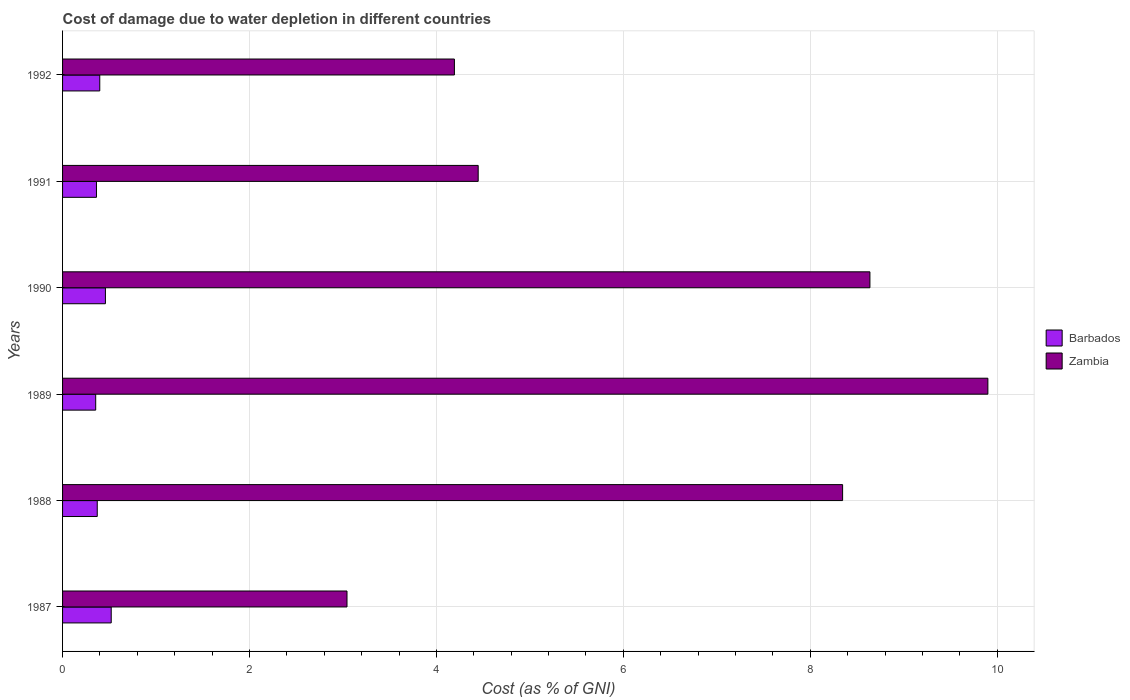Are the number of bars per tick equal to the number of legend labels?
Ensure brevity in your answer.  Yes. How many bars are there on the 6th tick from the top?
Your answer should be very brief. 2. What is the label of the 1st group of bars from the top?
Provide a short and direct response. 1992. What is the cost of damage caused due to water depletion in Zambia in 1991?
Provide a short and direct response. 4.45. Across all years, what is the maximum cost of damage caused due to water depletion in Barbados?
Keep it short and to the point. 0.52. Across all years, what is the minimum cost of damage caused due to water depletion in Zambia?
Your answer should be very brief. 3.04. In which year was the cost of damage caused due to water depletion in Barbados minimum?
Give a very brief answer. 1989. What is the total cost of damage caused due to water depletion in Zambia in the graph?
Ensure brevity in your answer.  38.57. What is the difference between the cost of damage caused due to water depletion in Barbados in 1990 and that in 1992?
Keep it short and to the point. 0.06. What is the difference between the cost of damage caused due to water depletion in Zambia in 1990 and the cost of damage caused due to water depletion in Barbados in 1989?
Your answer should be very brief. 8.28. What is the average cost of damage caused due to water depletion in Barbados per year?
Offer a terse response. 0.41. In the year 1987, what is the difference between the cost of damage caused due to water depletion in Zambia and cost of damage caused due to water depletion in Barbados?
Provide a succinct answer. 2.52. In how many years, is the cost of damage caused due to water depletion in Zambia greater than 7.6 %?
Offer a very short reply. 3. What is the ratio of the cost of damage caused due to water depletion in Zambia in 1987 to that in 1992?
Provide a succinct answer. 0.73. Is the cost of damage caused due to water depletion in Zambia in 1987 less than that in 1990?
Keep it short and to the point. Yes. What is the difference between the highest and the second highest cost of damage caused due to water depletion in Barbados?
Offer a very short reply. 0.06. What is the difference between the highest and the lowest cost of damage caused due to water depletion in Zambia?
Offer a very short reply. 6.86. What does the 1st bar from the top in 1989 represents?
Offer a terse response. Zambia. What does the 1st bar from the bottom in 1990 represents?
Keep it short and to the point. Barbados. Are all the bars in the graph horizontal?
Provide a succinct answer. Yes. How many years are there in the graph?
Make the answer very short. 6. Does the graph contain any zero values?
Make the answer very short. No. What is the title of the graph?
Your answer should be compact. Cost of damage due to water depletion in different countries. Does "Kosovo" appear as one of the legend labels in the graph?
Make the answer very short. No. What is the label or title of the X-axis?
Ensure brevity in your answer.  Cost (as % of GNI). What is the label or title of the Y-axis?
Provide a short and direct response. Years. What is the Cost (as % of GNI) in Barbados in 1987?
Your answer should be very brief. 0.52. What is the Cost (as % of GNI) in Zambia in 1987?
Your response must be concise. 3.04. What is the Cost (as % of GNI) in Barbados in 1988?
Give a very brief answer. 0.37. What is the Cost (as % of GNI) of Zambia in 1988?
Offer a very short reply. 8.35. What is the Cost (as % of GNI) in Barbados in 1989?
Make the answer very short. 0.35. What is the Cost (as % of GNI) in Zambia in 1989?
Offer a very short reply. 9.9. What is the Cost (as % of GNI) of Barbados in 1990?
Ensure brevity in your answer.  0.46. What is the Cost (as % of GNI) of Zambia in 1990?
Your response must be concise. 8.64. What is the Cost (as % of GNI) in Barbados in 1991?
Keep it short and to the point. 0.36. What is the Cost (as % of GNI) of Zambia in 1991?
Provide a short and direct response. 4.45. What is the Cost (as % of GNI) in Barbados in 1992?
Offer a very short reply. 0.4. What is the Cost (as % of GNI) of Zambia in 1992?
Offer a terse response. 4.19. Across all years, what is the maximum Cost (as % of GNI) in Barbados?
Give a very brief answer. 0.52. Across all years, what is the maximum Cost (as % of GNI) of Zambia?
Your response must be concise. 9.9. Across all years, what is the minimum Cost (as % of GNI) of Barbados?
Ensure brevity in your answer.  0.35. Across all years, what is the minimum Cost (as % of GNI) in Zambia?
Your answer should be very brief. 3.04. What is the total Cost (as % of GNI) of Barbados in the graph?
Your answer should be compact. 2.47. What is the total Cost (as % of GNI) of Zambia in the graph?
Make the answer very short. 38.57. What is the difference between the Cost (as % of GNI) in Barbados in 1987 and that in 1988?
Your answer should be very brief. 0.15. What is the difference between the Cost (as % of GNI) in Zambia in 1987 and that in 1988?
Ensure brevity in your answer.  -5.3. What is the difference between the Cost (as % of GNI) in Barbados in 1987 and that in 1989?
Make the answer very short. 0.17. What is the difference between the Cost (as % of GNI) of Zambia in 1987 and that in 1989?
Give a very brief answer. -6.86. What is the difference between the Cost (as % of GNI) of Barbados in 1987 and that in 1990?
Make the answer very short. 0.06. What is the difference between the Cost (as % of GNI) in Zambia in 1987 and that in 1990?
Give a very brief answer. -5.6. What is the difference between the Cost (as % of GNI) of Barbados in 1987 and that in 1991?
Your response must be concise. 0.16. What is the difference between the Cost (as % of GNI) in Zambia in 1987 and that in 1991?
Offer a very short reply. -1.4. What is the difference between the Cost (as % of GNI) of Barbados in 1987 and that in 1992?
Your answer should be compact. 0.12. What is the difference between the Cost (as % of GNI) of Zambia in 1987 and that in 1992?
Offer a very short reply. -1.15. What is the difference between the Cost (as % of GNI) of Barbados in 1988 and that in 1989?
Ensure brevity in your answer.  0.02. What is the difference between the Cost (as % of GNI) in Zambia in 1988 and that in 1989?
Give a very brief answer. -1.55. What is the difference between the Cost (as % of GNI) in Barbados in 1988 and that in 1990?
Give a very brief answer. -0.09. What is the difference between the Cost (as % of GNI) in Zambia in 1988 and that in 1990?
Keep it short and to the point. -0.29. What is the difference between the Cost (as % of GNI) in Barbados in 1988 and that in 1991?
Provide a succinct answer. 0.01. What is the difference between the Cost (as % of GNI) in Zambia in 1988 and that in 1991?
Offer a very short reply. 3.9. What is the difference between the Cost (as % of GNI) in Barbados in 1988 and that in 1992?
Offer a very short reply. -0.03. What is the difference between the Cost (as % of GNI) in Zambia in 1988 and that in 1992?
Your answer should be very brief. 4.15. What is the difference between the Cost (as % of GNI) of Barbados in 1989 and that in 1990?
Your answer should be compact. -0.1. What is the difference between the Cost (as % of GNI) in Zambia in 1989 and that in 1990?
Make the answer very short. 1.26. What is the difference between the Cost (as % of GNI) of Barbados in 1989 and that in 1991?
Give a very brief answer. -0.01. What is the difference between the Cost (as % of GNI) in Zambia in 1989 and that in 1991?
Give a very brief answer. 5.45. What is the difference between the Cost (as % of GNI) of Barbados in 1989 and that in 1992?
Offer a very short reply. -0.04. What is the difference between the Cost (as % of GNI) in Zambia in 1989 and that in 1992?
Give a very brief answer. 5.71. What is the difference between the Cost (as % of GNI) in Barbados in 1990 and that in 1991?
Provide a succinct answer. 0.1. What is the difference between the Cost (as % of GNI) of Zambia in 1990 and that in 1991?
Your answer should be very brief. 4.19. What is the difference between the Cost (as % of GNI) in Barbados in 1990 and that in 1992?
Your response must be concise. 0.06. What is the difference between the Cost (as % of GNI) in Zambia in 1990 and that in 1992?
Offer a very short reply. 4.45. What is the difference between the Cost (as % of GNI) in Barbados in 1991 and that in 1992?
Make the answer very short. -0.04. What is the difference between the Cost (as % of GNI) in Zambia in 1991 and that in 1992?
Your answer should be compact. 0.25. What is the difference between the Cost (as % of GNI) in Barbados in 1987 and the Cost (as % of GNI) in Zambia in 1988?
Offer a very short reply. -7.83. What is the difference between the Cost (as % of GNI) of Barbados in 1987 and the Cost (as % of GNI) of Zambia in 1989?
Your answer should be very brief. -9.38. What is the difference between the Cost (as % of GNI) of Barbados in 1987 and the Cost (as % of GNI) of Zambia in 1990?
Keep it short and to the point. -8.12. What is the difference between the Cost (as % of GNI) of Barbados in 1987 and the Cost (as % of GNI) of Zambia in 1991?
Keep it short and to the point. -3.93. What is the difference between the Cost (as % of GNI) in Barbados in 1987 and the Cost (as % of GNI) in Zambia in 1992?
Make the answer very short. -3.67. What is the difference between the Cost (as % of GNI) of Barbados in 1988 and the Cost (as % of GNI) of Zambia in 1989?
Make the answer very short. -9.53. What is the difference between the Cost (as % of GNI) of Barbados in 1988 and the Cost (as % of GNI) of Zambia in 1990?
Ensure brevity in your answer.  -8.27. What is the difference between the Cost (as % of GNI) of Barbados in 1988 and the Cost (as % of GNI) of Zambia in 1991?
Ensure brevity in your answer.  -4.08. What is the difference between the Cost (as % of GNI) in Barbados in 1988 and the Cost (as % of GNI) in Zambia in 1992?
Give a very brief answer. -3.82. What is the difference between the Cost (as % of GNI) in Barbados in 1989 and the Cost (as % of GNI) in Zambia in 1990?
Offer a very short reply. -8.28. What is the difference between the Cost (as % of GNI) of Barbados in 1989 and the Cost (as % of GNI) of Zambia in 1991?
Provide a succinct answer. -4.09. What is the difference between the Cost (as % of GNI) in Barbados in 1989 and the Cost (as % of GNI) in Zambia in 1992?
Keep it short and to the point. -3.84. What is the difference between the Cost (as % of GNI) of Barbados in 1990 and the Cost (as % of GNI) of Zambia in 1991?
Your response must be concise. -3.99. What is the difference between the Cost (as % of GNI) of Barbados in 1990 and the Cost (as % of GNI) of Zambia in 1992?
Ensure brevity in your answer.  -3.73. What is the difference between the Cost (as % of GNI) in Barbados in 1991 and the Cost (as % of GNI) in Zambia in 1992?
Your answer should be very brief. -3.83. What is the average Cost (as % of GNI) in Barbados per year?
Provide a succinct answer. 0.41. What is the average Cost (as % of GNI) of Zambia per year?
Your response must be concise. 6.43. In the year 1987, what is the difference between the Cost (as % of GNI) in Barbados and Cost (as % of GNI) in Zambia?
Ensure brevity in your answer.  -2.52. In the year 1988, what is the difference between the Cost (as % of GNI) in Barbados and Cost (as % of GNI) in Zambia?
Ensure brevity in your answer.  -7.97. In the year 1989, what is the difference between the Cost (as % of GNI) of Barbados and Cost (as % of GNI) of Zambia?
Provide a succinct answer. -9.55. In the year 1990, what is the difference between the Cost (as % of GNI) in Barbados and Cost (as % of GNI) in Zambia?
Provide a succinct answer. -8.18. In the year 1991, what is the difference between the Cost (as % of GNI) of Barbados and Cost (as % of GNI) of Zambia?
Make the answer very short. -4.08. In the year 1992, what is the difference between the Cost (as % of GNI) in Barbados and Cost (as % of GNI) in Zambia?
Keep it short and to the point. -3.79. What is the ratio of the Cost (as % of GNI) of Barbados in 1987 to that in 1988?
Provide a short and direct response. 1.4. What is the ratio of the Cost (as % of GNI) of Zambia in 1987 to that in 1988?
Offer a very short reply. 0.36. What is the ratio of the Cost (as % of GNI) of Barbados in 1987 to that in 1989?
Keep it short and to the point. 1.47. What is the ratio of the Cost (as % of GNI) in Zambia in 1987 to that in 1989?
Keep it short and to the point. 0.31. What is the ratio of the Cost (as % of GNI) of Barbados in 1987 to that in 1990?
Keep it short and to the point. 1.14. What is the ratio of the Cost (as % of GNI) in Zambia in 1987 to that in 1990?
Provide a succinct answer. 0.35. What is the ratio of the Cost (as % of GNI) of Barbados in 1987 to that in 1991?
Offer a very short reply. 1.44. What is the ratio of the Cost (as % of GNI) in Zambia in 1987 to that in 1991?
Your answer should be very brief. 0.68. What is the ratio of the Cost (as % of GNI) of Barbados in 1987 to that in 1992?
Provide a succinct answer. 1.31. What is the ratio of the Cost (as % of GNI) of Zambia in 1987 to that in 1992?
Your answer should be compact. 0.73. What is the ratio of the Cost (as % of GNI) in Barbados in 1988 to that in 1989?
Offer a terse response. 1.05. What is the ratio of the Cost (as % of GNI) of Zambia in 1988 to that in 1989?
Your answer should be very brief. 0.84. What is the ratio of the Cost (as % of GNI) of Barbados in 1988 to that in 1990?
Your answer should be compact. 0.81. What is the ratio of the Cost (as % of GNI) in Zambia in 1988 to that in 1990?
Keep it short and to the point. 0.97. What is the ratio of the Cost (as % of GNI) in Barbados in 1988 to that in 1991?
Your answer should be very brief. 1.02. What is the ratio of the Cost (as % of GNI) of Zambia in 1988 to that in 1991?
Make the answer very short. 1.88. What is the ratio of the Cost (as % of GNI) of Barbados in 1988 to that in 1992?
Your answer should be compact. 0.93. What is the ratio of the Cost (as % of GNI) of Zambia in 1988 to that in 1992?
Offer a very short reply. 1.99. What is the ratio of the Cost (as % of GNI) of Barbados in 1989 to that in 1990?
Your response must be concise. 0.77. What is the ratio of the Cost (as % of GNI) of Zambia in 1989 to that in 1990?
Provide a short and direct response. 1.15. What is the ratio of the Cost (as % of GNI) in Barbados in 1989 to that in 1991?
Your response must be concise. 0.98. What is the ratio of the Cost (as % of GNI) in Zambia in 1989 to that in 1991?
Make the answer very short. 2.23. What is the ratio of the Cost (as % of GNI) in Barbados in 1989 to that in 1992?
Ensure brevity in your answer.  0.89. What is the ratio of the Cost (as % of GNI) of Zambia in 1989 to that in 1992?
Your answer should be very brief. 2.36. What is the ratio of the Cost (as % of GNI) in Barbados in 1990 to that in 1991?
Provide a short and direct response. 1.26. What is the ratio of the Cost (as % of GNI) in Zambia in 1990 to that in 1991?
Provide a short and direct response. 1.94. What is the ratio of the Cost (as % of GNI) in Barbados in 1990 to that in 1992?
Keep it short and to the point. 1.15. What is the ratio of the Cost (as % of GNI) in Zambia in 1990 to that in 1992?
Offer a terse response. 2.06. What is the ratio of the Cost (as % of GNI) of Barbados in 1991 to that in 1992?
Your answer should be very brief. 0.91. What is the ratio of the Cost (as % of GNI) of Zambia in 1991 to that in 1992?
Give a very brief answer. 1.06. What is the difference between the highest and the second highest Cost (as % of GNI) in Barbados?
Make the answer very short. 0.06. What is the difference between the highest and the second highest Cost (as % of GNI) of Zambia?
Make the answer very short. 1.26. What is the difference between the highest and the lowest Cost (as % of GNI) in Barbados?
Keep it short and to the point. 0.17. What is the difference between the highest and the lowest Cost (as % of GNI) of Zambia?
Your response must be concise. 6.86. 